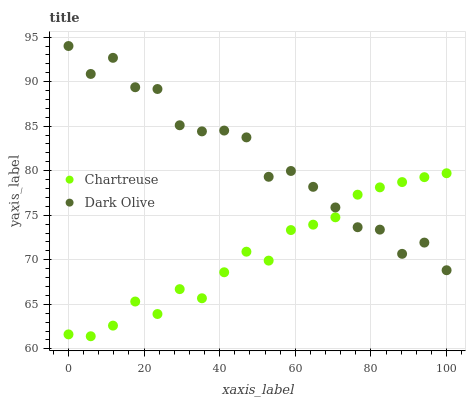Does Chartreuse have the minimum area under the curve?
Answer yes or no. Yes. Does Dark Olive have the maximum area under the curve?
Answer yes or no. Yes. Does Dark Olive have the minimum area under the curve?
Answer yes or no. No. Is Chartreuse the smoothest?
Answer yes or no. Yes. Is Dark Olive the roughest?
Answer yes or no. Yes. Is Dark Olive the smoothest?
Answer yes or no. No. Does Chartreuse have the lowest value?
Answer yes or no. Yes. Does Dark Olive have the lowest value?
Answer yes or no. No. Does Dark Olive have the highest value?
Answer yes or no. Yes. Does Dark Olive intersect Chartreuse?
Answer yes or no. Yes. Is Dark Olive less than Chartreuse?
Answer yes or no. No. Is Dark Olive greater than Chartreuse?
Answer yes or no. No. 